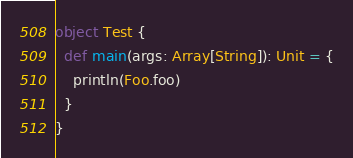Convert code to text. <code><loc_0><loc_0><loc_500><loc_500><_Scala_>
object Test {
  def main(args: Array[String]): Unit = {
    println(Foo.foo)
  }
}
</code> 